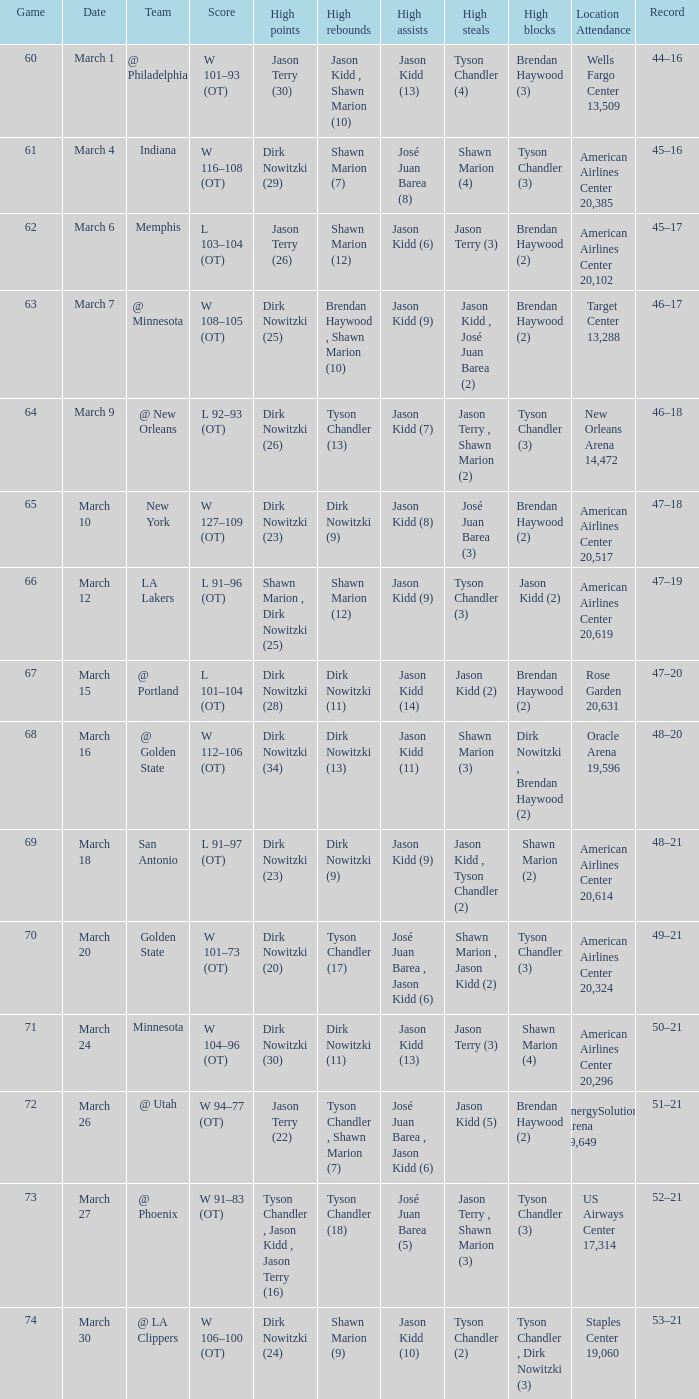Name the high points for march 30 Dirk Nowitzki (24). 